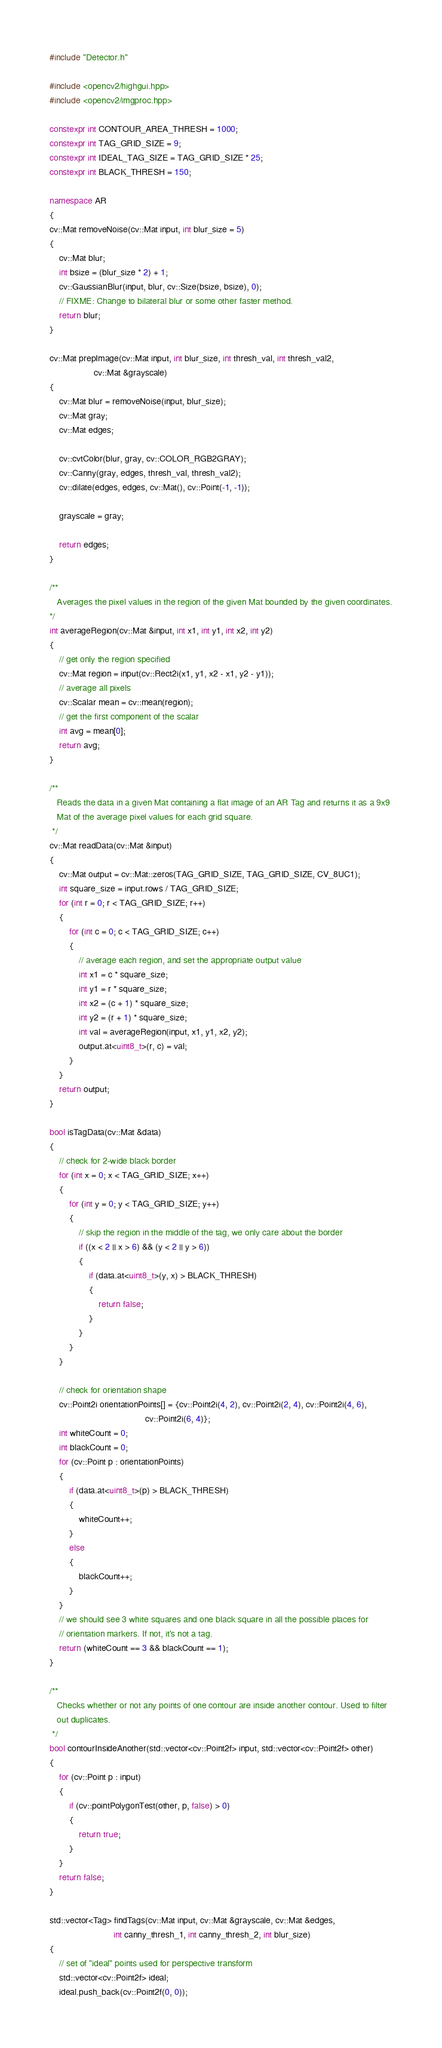<code> <loc_0><loc_0><loc_500><loc_500><_C++_>#include "Detector.h"

#include <opencv2/highgui.hpp>
#include <opencv2/imgproc.hpp>

constexpr int CONTOUR_AREA_THRESH = 1000;
constexpr int TAG_GRID_SIZE = 9;
constexpr int IDEAL_TAG_SIZE = TAG_GRID_SIZE * 25;
constexpr int BLACK_THRESH = 150;

namespace AR
{
cv::Mat removeNoise(cv::Mat input, int blur_size = 5)
{
	cv::Mat blur;
	int bsize = (blur_size * 2) + 1;
	cv::GaussianBlur(input, blur, cv::Size(bsize, bsize), 0);
	// FIXME: Change to bilateral blur or some other faster method.
	return blur;
}

cv::Mat prepImage(cv::Mat input, int blur_size, int thresh_val, int thresh_val2,
                  cv::Mat &grayscale)
{
	cv::Mat blur = removeNoise(input, blur_size);
	cv::Mat gray;
	cv::Mat edges;

	cv::cvtColor(blur, gray, cv::COLOR_RGB2GRAY);
	cv::Canny(gray, edges, thresh_val, thresh_val2);
	cv::dilate(edges, edges, cv::Mat(), cv::Point(-1, -1));

	grayscale = gray;

	return edges;
}

/**
   Averages the pixel values in the region of the given Mat bounded by the given coordinates.
*/
int averageRegion(cv::Mat &input, int x1, int y1, int x2, int y2)
{
	// get only the region specified
	cv::Mat region = input(cv::Rect2i(x1, y1, x2 - x1, y2 - y1));
	// average all pixels
	cv::Scalar mean = cv::mean(region);
	// get the first component of the scalar
	int avg = mean[0];
	return avg;
}

/**
   Reads the data in a given Mat containing a flat image of an AR Tag and returns it as a 9x9
   Mat of the average pixel values for each grid square.
 */
cv::Mat readData(cv::Mat &input)
{
	cv::Mat output = cv::Mat::zeros(TAG_GRID_SIZE, TAG_GRID_SIZE, CV_8UC1);
	int square_size = input.rows / TAG_GRID_SIZE;
	for (int r = 0; r < TAG_GRID_SIZE; r++)
	{
		for (int c = 0; c < TAG_GRID_SIZE; c++)
		{
			// average each region, and set the appropriate output value
			int x1 = c * square_size;
			int y1 = r * square_size;
			int x2 = (c + 1) * square_size;
			int y2 = (r + 1) * square_size;
			int val = averageRegion(input, x1, y1, x2, y2);
			output.at<uint8_t>(r, c) = val;
		}
	}
	return output;
}

bool isTagData(cv::Mat &data)
{
	// check for 2-wide black border
	for (int x = 0; x < TAG_GRID_SIZE; x++)
	{
		for (int y = 0; y < TAG_GRID_SIZE; y++)
		{
			// skip the region in the middle of the tag, we only care about the border
			if ((x < 2 || x > 6) && (y < 2 || y > 6))
			{
				if (data.at<uint8_t>(y, x) > BLACK_THRESH)
				{
					return false;
				}
			}
		}
	}

	// check for orientation shape
	cv::Point2i orientationPoints[] = {cv::Point2i(4, 2), cv::Point2i(2, 4), cv::Point2i(4, 6),
	                                   cv::Point2i(6, 4)};
	int whiteCount = 0;
	int blackCount = 0;
	for (cv::Point p : orientationPoints)
	{
		if (data.at<uint8_t>(p) > BLACK_THRESH)
		{
			whiteCount++;
		}
		else
		{
			blackCount++;
		}
	}
	// we should see 3 white squares and one black square in all the possible places for
	// orientation markers. If not, it's not a tag.
	return (whiteCount == 3 && blackCount == 1);
}

/**
   Checks whether or not any points of one contour are inside another contour. Used to filter
   out duplicates.
 */
bool contourInsideAnother(std::vector<cv::Point2f> input, std::vector<cv::Point2f> other)
{
	for (cv::Point p : input)
	{
		if (cv::pointPolygonTest(other, p, false) > 0)
		{
			return true;
		}
	}
	return false;
}

std::vector<Tag> findTags(cv::Mat input, cv::Mat &grayscale, cv::Mat &edges,
                          int canny_thresh_1, int canny_thresh_2, int blur_size)
{
	// set of "ideal" points used for perspective transform
	std::vector<cv::Point2f> ideal;
	ideal.push_back(cv::Point2f(0, 0));</code> 